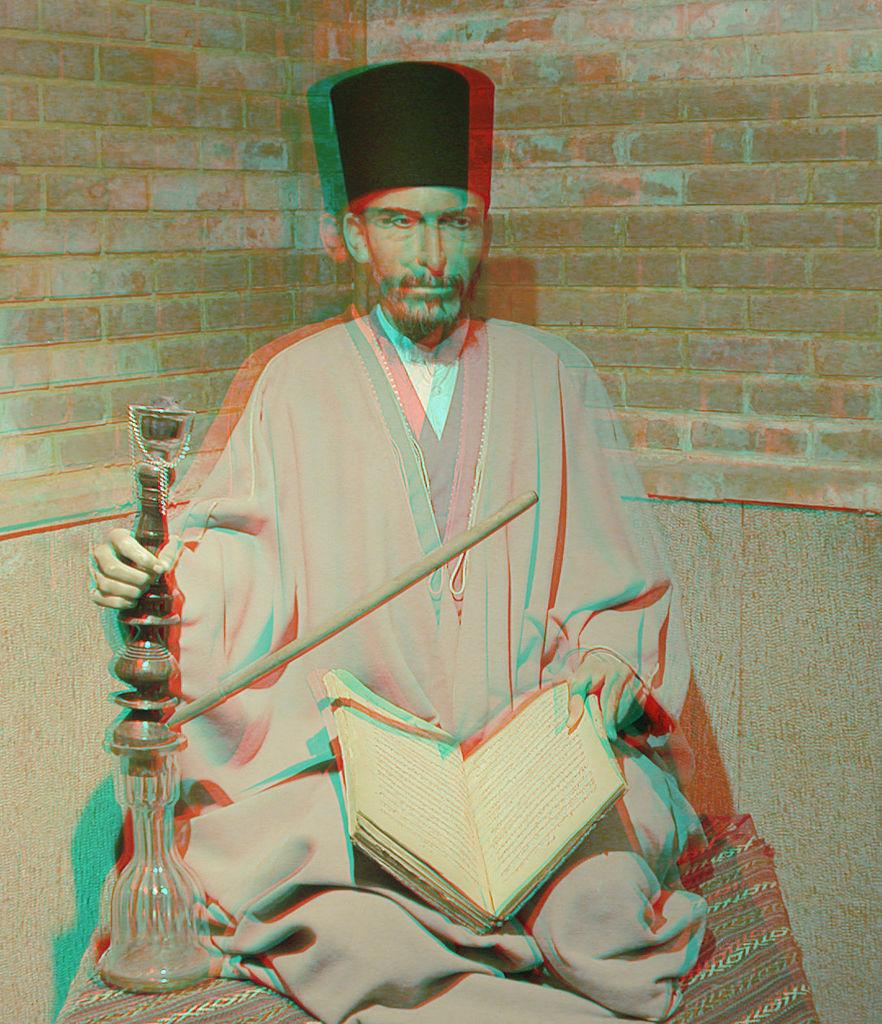Who is present in the image? There is a man in the image. What is the man sitting on? The man is sitting on a cloth. What is the man holding in his hand? The man is holding a book in his hand. What else is the man holding in his other hand? The man has a hookah with a pipe in his other hand. What can be seen in the background of the image? There is a brick wall in the background of the image. What type of orange is the man using to show the tray in the image? There is no orange or tray present in the image. 